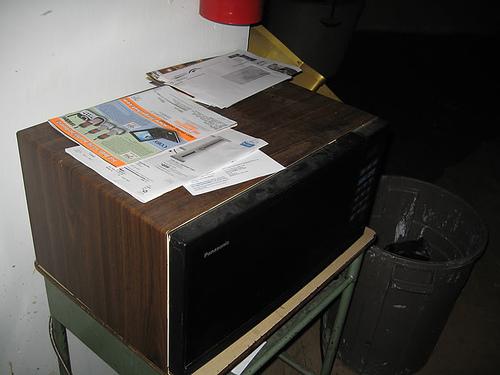Is that a box in the picture?
Be succinct. No. Are there magazines in this picture?
Write a very short answer. Yes. What color is the garbage can?
Short answer required. Gray. What is this device?
Be succinct. Microwave. Is there trash in the garbage can?
Quick response, please. Yes. Where is the magazine?
Concise answer only. Microwave. 